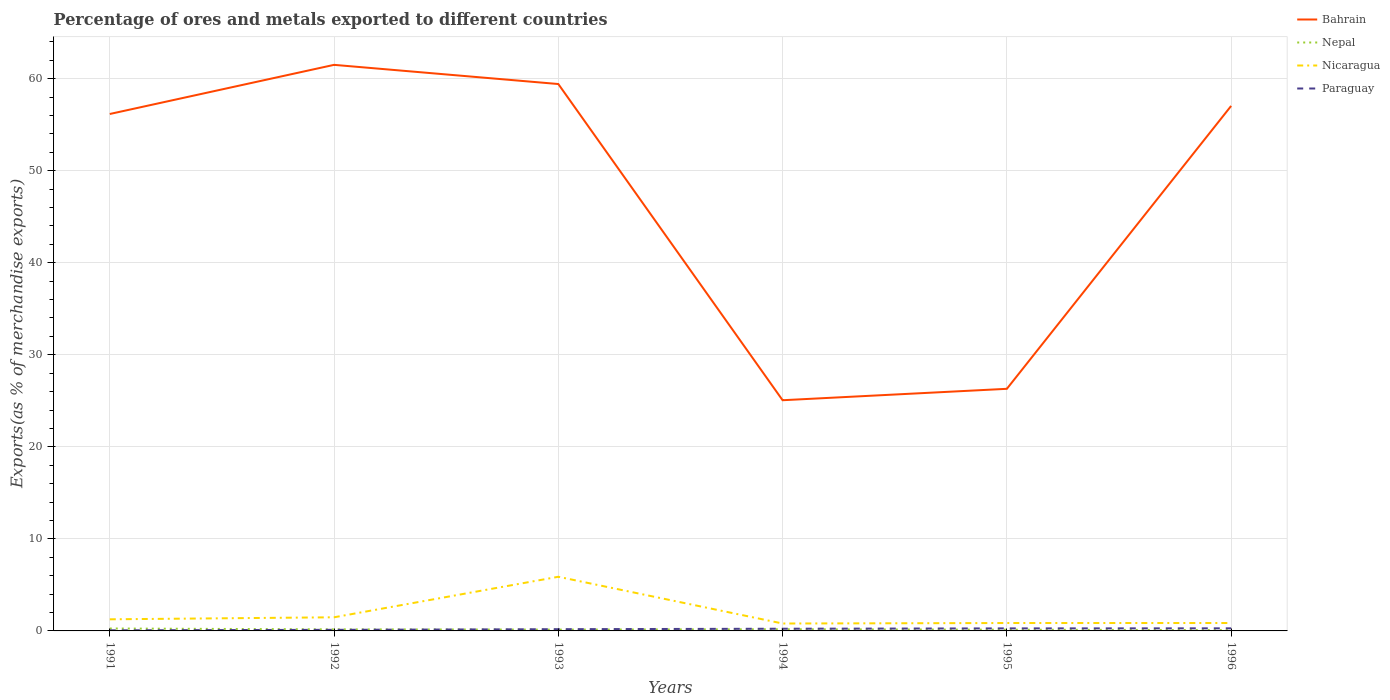How many different coloured lines are there?
Give a very brief answer. 4. Does the line corresponding to Bahrain intersect with the line corresponding to Paraguay?
Your response must be concise. No. Across all years, what is the maximum percentage of exports to different countries in Paraguay?
Provide a succinct answer. 0.06. In which year was the percentage of exports to different countries in Paraguay maximum?
Ensure brevity in your answer.  1991. What is the total percentage of exports to different countries in Nicaragua in the graph?
Ensure brevity in your answer.  5.03. What is the difference between the highest and the second highest percentage of exports to different countries in Bahrain?
Provide a short and direct response. 36.44. What is the difference between two consecutive major ticks on the Y-axis?
Provide a short and direct response. 10. Are the values on the major ticks of Y-axis written in scientific E-notation?
Your answer should be very brief. No. Does the graph contain any zero values?
Give a very brief answer. No. Does the graph contain grids?
Provide a succinct answer. Yes. How are the legend labels stacked?
Offer a very short reply. Vertical. What is the title of the graph?
Ensure brevity in your answer.  Percentage of ores and metals exported to different countries. Does "Small states" appear as one of the legend labels in the graph?
Ensure brevity in your answer.  No. What is the label or title of the Y-axis?
Give a very brief answer. Exports(as % of merchandise exports). What is the Exports(as % of merchandise exports) in Bahrain in 1991?
Offer a very short reply. 56.17. What is the Exports(as % of merchandise exports) in Nepal in 1991?
Keep it short and to the point. 0.26. What is the Exports(as % of merchandise exports) of Nicaragua in 1991?
Keep it short and to the point. 1.26. What is the Exports(as % of merchandise exports) in Paraguay in 1991?
Your answer should be very brief. 0.06. What is the Exports(as % of merchandise exports) in Bahrain in 1992?
Keep it short and to the point. 61.5. What is the Exports(as % of merchandise exports) of Nepal in 1992?
Your response must be concise. 0.17. What is the Exports(as % of merchandise exports) in Nicaragua in 1992?
Offer a very short reply. 1.48. What is the Exports(as % of merchandise exports) of Paraguay in 1992?
Make the answer very short. 0.12. What is the Exports(as % of merchandise exports) of Bahrain in 1993?
Ensure brevity in your answer.  59.42. What is the Exports(as % of merchandise exports) of Nepal in 1993?
Provide a succinct answer. 0.14. What is the Exports(as % of merchandise exports) in Nicaragua in 1993?
Provide a succinct answer. 5.88. What is the Exports(as % of merchandise exports) in Paraguay in 1993?
Give a very brief answer. 0.19. What is the Exports(as % of merchandise exports) of Bahrain in 1994?
Your answer should be very brief. 25.07. What is the Exports(as % of merchandise exports) in Nepal in 1994?
Your answer should be compact. 0.19. What is the Exports(as % of merchandise exports) of Nicaragua in 1994?
Offer a terse response. 0.81. What is the Exports(as % of merchandise exports) of Paraguay in 1994?
Your response must be concise. 0.24. What is the Exports(as % of merchandise exports) of Bahrain in 1995?
Your answer should be very brief. 26.31. What is the Exports(as % of merchandise exports) of Nepal in 1995?
Your answer should be very brief. 0.13. What is the Exports(as % of merchandise exports) in Nicaragua in 1995?
Your answer should be compact. 0.86. What is the Exports(as % of merchandise exports) of Paraguay in 1995?
Offer a very short reply. 0.27. What is the Exports(as % of merchandise exports) of Bahrain in 1996?
Offer a very short reply. 57.04. What is the Exports(as % of merchandise exports) of Nepal in 1996?
Offer a very short reply. 0.09. What is the Exports(as % of merchandise exports) of Nicaragua in 1996?
Make the answer very short. 0.86. What is the Exports(as % of merchandise exports) in Paraguay in 1996?
Ensure brevity in your answer.  0.28. Across all years, what is the maximum Exports(as % of merchandise exports) in Bahrain?
Provide a succinct answer. 61.5. Across all years, what is the maximum Exports(as % of merchandise exports) in Nepal?
Offer a terse response. 0.26. Across all years, what is the maximum Exports(as % of merchandise exports) of Nicaragua?
Your response must be concise. 5.88. Across all years, what is the maximum Exports(as % of merchandise exports) in Paraguay?
Give a very brief answer. 0.28. Across all years, what is the minimum Exports(as % of merchandise exports) of Bahrain?
Ensure brevity in your answer.  25.07. Across all years, what is the minimum Exports(as % of merchandise exports) in Nepal?
Offer a very short reply. 0.09. Across all years, what is the minimum Exports(as % of merchandise exports) of Nicaragua?
Your answer should be very brief. 0.81. Across all years, what is the minimum Exports(as % of merchandise exports) in Paraguay?
Keep it short and to the point. 0.06. What is the total Exports(as % of merchandise exports) of Bahrain in the graph?
Offer a terse response. 285.5. What is the total Exports(as % of merchandise exports) in Nepal in the graph?
Provide a short and direct response. 0.98. What is the total Exports(as % of merchandise exports) in Nicaragua in the graph?
Provide a succinct answer. 11.15. What is the total Exports(as % of merchandise exports) of Paraguay in the graph?
Ensure brevity in your answer.  1.17. What is the difference between the Exports(as % of merchandise exports) of Bahrain in 1991 and that in 1992?
Keep it short and to the point. -5.34. What is the difference between the Exports(as % of merchandise exports) in Nepal in 1991 and that in 1992?
Provide a short and direct response. 0.09. What is the difference between the Exports(as % of merchandise exports) in Nicaragua in 1991 and that in 1992?
Your answer should be compact. -0.22. What is the difference between the Exports(as % of merchandise exports) of Paraguay in 1991 and that in 1992?
Provide a short and direct response. -0.06. What is the difference between the Exports(as % of merchandise exports) in Bahrain in 1991 and that in 1993?
Offer a very short reply. -3.25. What is the difference between the Exports(as % of merchandise exports) in Nepal in 1991 and that in 1993?
Your response must be concise. 0.12. What is the difference between the Exports(as % of merchandise exports) of Nicaragua in 1991 and that in 1993?
Your answer should be compact. -4.62. What is the difference between the Exports(as % of merchandise exports) in Paraguay in 1991 and that in 1993?
Keep it short and to the point. -0.12. What is the difference between the Exports(as % of merchandise exports) of Bahrain in 1991 and that in 1994?
Offer a terse response. 31.1. What is the difference between the Exports(as % of merchandise exports) in Nepal in 1991 and that in 1994?
Provide a succinct answer. 0.08. What is the difference between the Exports(as % of merchandise exports) of Nicaragua in 1991 and that in 1994?
Provide a succinct answer. 0.46. What is the difference between the Exports(as % of merchandise exports) in Paraguay in 1991 and that in 1994?
Provide a succinct answer. -0.18. What is the difference between the Exports(as % of merchandise exports) in Bahrain in 1991 and that in 1995?
Make the answer very short. 29.86. What is the difference between the Exports(as % of merchandise exports) of Nepal in 1991 and that in 1995?
Offer a very short reply. 0.13. What is the difference between the Exports(as % of merchandise exports) of Nicaragua in 1991 and that in 1995?
Give a very brief answer. 0.4. What is the difference between the Exports(as % of merchandise exports) of Paraguay in 1991 and that in 1995?
Give a very brief answer. -0.21. What is the difference between the Exports(as % of merchandise exports) in Bahrain in 1991 and that in 1996?
Make the answer very short. -0.88. What is the difference between the Exports(as % of merchandise exports) in Nepal in 1991 and that in 1996?
Give a very brief answer. 0.17. What is the difference between the Exports(as % of merchandise exports) of Nicaragua in 1991 and that in 1996?
Keep it short and to the point. 0.4. What is the difference between the Exports(as % of merchandise exports) in Paraguay in 1991 and that in 1996?
Your answer should be very brief. -0.22. What is the difference between the Exports(as % of merchandise exports) in Bahrain in 1992 and that in 1993?
Ensure brevity in your answer.  2.08. What is the difference between the Exports(as % of merchandise exports) of Nepal in 1992 and that in 1993?
Your answer should be very brief. 0.03. What is the difference between the Exports(as % of merchandise exports) in Nicaragua in 1992 and that in 1993?
Make the answer very short. -4.4. What is the difference between the Exports(as % of merchandise exports) of Paraguay in 1992 and that in 1993?
Offer a terse response. -0.07. What is the difference between the Exports(as % of merchandise exports) in Bahrain in 1992 and that in 1994?
Offer a very short reply. 36.44. What is the difference between the Exports(as % of merchandise exports) of Nepal in 1992 and that in 1994?
Offer a terse response. -0.02. What is the difference between the Exports(as % of merchandise exports) in Nicaragua in 1992 and that in 1994?
Offer a very short reply. 0.68. What is the difference between the Exports(as % of merchandise exports) of Paraguay in 1992 and that in 1994?
Provide a succinct answer. -0.12. What is the difference between the Exports(as % of merchandise exports) in Bahrain in 1992 and that in 1995?
Your answer should be very brief. 35.2. What is the difference between the Exports(as % of merchandise exports) of Nepal in 1992 and that in 1995?
Provide a short and direct response. 0.04. What is the difference between the Exports(as % of merchandise exports) of Nicaragua in 1992 and that in 1995?
Make the answer very short. 0.62. What is the difference between the Exports(as % of merchandise exports) of Paraguay in 1992 and that in 1995?
Provide a short and direct response. -0.16. What is the difference between the Exports(as % of merchandise exports) of Bahrain in 1992 and that in 1996?
Provide a short and direct response. 4.46. What is the difference between the Exports(as % of merchandise exports) of Nepal in 1992 and that in 1996?
Your answer should be very brief. 0.08. What is the difference between the Exports(as % of merchandise exports) in Nicaragua in 1992 and that in 1996?
Provide a succinct answer. 0.62. What is the difference between the Exports(as % of merchandise exports) in Paraguay in 1992 and that in 1996?
Make the answer very short. -0.16. What is the difference between the Exports(as % of merchandise exports) of Bahrain in 1993 and that in 1994?
Ensure brevity in your answer.  34.35. What is the difference between the Exports(as % of merchandise exports) of Nepal in 1993 and that in 1994?
Ensure brevity in your answer.  -0.04. What is the difference between the Exports(as % of merchandise exports) in Nicaragua in 1993 and that in 1994?
Your answer should be very brief. 5.08. What is the difference between the Exports(as % of merchandise exports) of Paraguay in 1993 and that in 1994?
Offer a terse response. -0.05. What is the difference between the Exports(as % of merchandise exports) of Bahrain in 1993 and that in 1995?
Your answer should be very brief. 33.11. What is the difference between the Exports(as % of merchandise exports) in Nepal in 1993 and that in 1995?
Your answer should be very brief. 0.01. What is the difference between the Exports(as % of merchandise exports) of Nicaragua in 1993 and that in 1995?
Your answer should be compact. 5.03. What is the difference between the Exports(as % of merchandise exports) of Paraguay in 1993 and that in 1995?
Offer a terse response. -0.09. What is the difference between the Exports(as % of merchandise exports) in Bahrain in 1993 and that in 1996?
Your response must be concise. 2.38. What is the difference between the Exports(as % of merchandise exports) in Nepal in 1993 and that in 1996?
Provide a succinct answer. 0.05. What is the difference between the Exports(as % of merchandise exports) of Nicaragua in 1993 and that in 1996?
Make the answer very short. 5.02. What is the difference between the Exports(as % of merchandise exports) in Paraguay in 1993 and that in 1996?
Your answer should be very brief. -0.09. What is the difference between the Exports(as % of merchandise exports) in Bahrain in 1994 and that in 1995?
Offer a very short reply. -1.24. What is the difference between the Exports(as % of merchandise exports) of Nepal in 1994 and that in 1995?
Ensure brevity in your answer.  0.05. What is the difference between the Exports(as % of merchandise exports) in Nicaragua in 1994 and that in 1995?
Offer a terse response. -0.05. What is the difference between the Exports(as % of merchandise exports) in Paraguay in 1994 and that in 1995?
Make the answer very short. -0.04. What is the difference between the Exports(as % of merchandise exports) of Bahrain in 1994 and that in 1996?
Your answer should be very brief. -31.98. What is the difference between the Exports(as % of merchandise exports) in Nepal in 1994 and that in 1996?
Give a very brief answer. 0.1. What is the difference between the Exports(as % of merchandise exports) in Nicaragua in 1994 and that in 1996?
Your answer should be very brief. -0.05. What is the difference between the Exports(as % of merchandise exports) in Paraguay in 1994 and that in 1996?
Keep it short and to the point. -0.04. What is the difference between the Exports(as % of merchandise exports) of Bahrain in 1995 and that in 1996?
Your response must be concise. -30.74. What is the difference between the Exports(as % of merchandise exports) of Nepal in 1995 and that in 1996?
Your answer should be compact. 0.05. What is the difference between the Exports(as % of merchandise exports) in Nicaragua in 1995 and that in 1996?
Offer a very short reply. -0. What is the difference between the Exports(as % of merchandise exports) in Paraguay in 1995 and that in 1996?
Your response must be concise. -0.01. What is the difference between the Exports(as % of merchandise exports) of Bahrain in 1991 and the Exports(as % of merchandise exports) of Nepal in 1992?
Offer a terse response. 56. What is the difference between the Exports(as % of merchandise exports) in Bahrain in 1991 and the Exports(as % of merchandise exports) in Nicaragua in 1992?
Your answer should be very brief. 54.68. What is the difference between the Exports(as % of merchandise exports) in Bahrain in 1991 and the Exports(as % of merchandise exports) in Paraguay in 1992?
Give a very brief answer. 56.05. What is the difference between the Exports(as % of merchandise exports) in Nepal in 1991 and the Exports(as % of merchandise exports) in Nicaragua in 1992?
Provide a succinct answer. -1.22. What is the difference between the Exports(as % of merchandise exports) in Nepal in 1991 and the Exports(as % of merchandise exports) in Paraguay in 1992?
Ensure brevity in your answer.  0.14. What is the difference between the Exports(as % of merchandise exports) in Nicaragua in 1991 and the Exports(as % of merchandise exports) in Paraguay in 1992?
Offer a terse response. 1.14. What is the difference between the Exports(as % of merchandise exports) of Bahrain in 1991 and the Exports(as % of merchandise exports) of Nepal in 1993?
Offer a very short reply. 56.02. What is the difference between the Exports(as % of merchandise exports) in Bahrain in 1991 and the Exports(as % of merchandise exports) in Nicaragua in 1993?
Give a very brief answer. 50.28. What is the difference between the Exports(as % of merchandise exports) of Bahrain in 1991 and the Exports(as % of merchandise exports) of Paraguay in 1993?
Your response must be concise. 55.98. What is the difference between the Exports(as % of merchandise exports) in Nepal in 1991 and the Exports(as % of merchandise exports) in Nicaragua in 1993?
Make the answer very short. -5.62. What is the difference between the Exports(as % of merchandise exports) of Nepal in 1991 and the Exports(as % of merchandise exports) of Paraguay in 1993?
Your response must be concise. 0.07. What is the difference between the Exports(as % of merchandise exports) of Nicaragua in 1991 and the Exports(as % of merchandise exports) of Paraguay in 1993?
Give a very brief answer. 1.07. What is the difference between the Exports(as % of merchandise exports) of Bahrain in 1991 and the Exports(as % of merchandise exports) of Nepal in 1994?
Your response must be concise. 55.98. What is the difference between the Exports(as % of merchandise exports) of Bahrain in 1991 and the Exports(as % of merchandise exports) of Nicaragua in 1994?
Make the answer very short. 55.36. What is the difference between the Exports(as % of merchandise exports) in Bahrain in 1991 and the Exports(as % of merchandise exports) in Paraguay in 1994?
Keep it short and to the point. 55.93. What is the difference between the Exports(as % of merchandise exports) of Nepal in 1991 and the Exports(as % of merchandise exports) of Nicaragua in 1994?
Provide a succinct answer. -0.54. What is the difference between the Exports(as % of merchandise exports) of Nepal in 1991 and the Exports(as % of merchandise exports) of Paraguay in 1994?
Offer a very short reply. 0.02. What is the difference between the Exports(as % of merchandise exports) in Nicaragua in 1991 and the Exports(as % of merchandise exports) in Paraguay in 1994?
Offer a terse response. 1.02. What is the difference between the Exports(as % of merchandise exports) in Bahrain in 1991 and the Exports(as % of merchandise exports) in Nepal in 1995?
Ensure brevity in your answer.  56.03. What is the difference between the Exports(as % of merchandise exports) in Bahrain in 1991 and the Exports(as % of merchandise exports) in Nicaragua in 1995?
Offer a very short reply. 55.31. What is the difference between the Exports(as % of merchandise exports) of Bahrain in 1991 and the Exports(as % of merchandise exports) of Paraguay in 1995?
Your answer should be very brief. 55.89. What is the difference between the Exports(as % of merchandise exports) of Nepal in 1991 and the Exports(as % of merchandise exports) of Nicaragua in 1995?
Your answer should be compact. -0.6. What is the difference between the Exports(as % of merchandise exports) in Nepal in 1991 and the Exports(as % of merchandise exports) in Paraguay in 1995?
Your response must be concise. -0.01. What is the difference between the Exports(as % of merchandise exports) in Nicaragua in 1991 and the Exports(as % of merchandise exports) in Paraguay in 1995?
Ensure brevity in your answer.  0.99. What is the difference between the Exports(as % of merchandise exports) of Bahrain in 1991 and the Exports(as % of merchandise exports) of Nepal in 1996?
Your answer should be very brief. 56.08. What is the difference between the Exports(as % of merchandise exports) of Bahrain in 1991 and the Exports(as % of merchandise exports) of Nicaragua in 1996?
Keep it short and to the point. 55.31. What is the difference between the Exports(as % of merchandise exports) in Bahrain in 1991 and the Exports(as % of merchandise exports) in Paraguay in 1996?
Give a very brief answer. 55.88. What is the difference between the Exports(as % of merchandise exports) in Nepal in 1991 and the Exports(as % of merchandise exports) in Nicaragua in 1996?
Your answer should be very brief. -0.6. What is the difference between the Exports(as % of merchandise exports) in Nepal in 1991 and the Exports(as % of merchandise exports) in Paraguay in 1996?
Provide a short and direct response. -0.02. What is the difference between the Exports(as % of merchandise exports) of Nicaragua in 1991 and the Exports(as % of merchandise exports) of Paraguay in 1996?
Ensure brevity in your answer.  0.98. What is the difference between the Exports(as % of merchandise exports) in Bahrain in 1992 and the Exports(as % of merchandise exports) in Nepal in 1993?
Keep it short and to the point. 61.36. What is the difference between the Exports(as % of merchandise exports) of Bahrain in 1992 and the Exports(as % of merchandise exports) of Nicaragua in 1993?
Provide a short and direct response. 55.62. What is the difference between the Exports(as % of merchandise exports) of Bahrain in 1992 and the Exports(as % of merchandise exports) of Paraguay in 1993?
Your answer should be very brief. 61.32. What is the difference between the Exports(as % of merchandise exports) of Nepal in 1992 and the Exports(as % of merchandise exports) of Nicaragua in 1993?
Your answer should be very brief. -5.71. What is the difference between the Exports(as % of merchandise exports) in Nepal in 1992 and the Exports(as % of merchandise exports) in Paraguay in 1993?
Provide a short and direct response. -0.02. What is the difference between the Exports(as % of merchandise exports) in Nicaragua in 1992 and the Exports(as % of merchandise exports) in Paraguay in 1993?
Offer a terse response. 1.29. What is the difference between the Exports(as % of merchandise exports) in Bahrain in 1992 and the Exports(as % of merchandise exports) in Nepal in 1994?
Provide a succinct answer. 61.32. What is the difference between the Exports(as % of merchandise exports) in Bahrain in 1992 and the Exports(as % of merchandise exports) in Nicaragua in 1994?
Your response must be concise. 60.7. What is the difference between the Exports(as % of merchandise exports) of Bahrain in 1992 and the Exports(as % of merchandise exports) of Paraguay in 1994?
Ensure brevity in your answer.  61.27. What is the difference between the Exports(as % of merchandise exports) in Nepal in 1992 and the Exports(as % of merchandise exports) in Nicaragua in 1994?
Your answer should be compact. -0.64. What is the difference between the Exports(as % of merchandise exports) in Nepal in 1992 and the Exports(as % of merchandise exports) in Paraguay in 1994?
Your answer should be compact. -0.07. What is the difference between the Exports(as % of merchandise exports) of Nicaragua in 1992 and the Exports(as % of merchandise exports) of Paraguay in 1994?
Provide a succinct answer. 1.24. What is the difference between the Exports(as % of merchandise exports) in Bahrain in 1992 and the Exports(as % of merchandise exports) in Nepal in 1995?
Offer a very short reply. 61.37. What is the difference between the Exports(as % of merchandise exports) in Bahrain in 1992 and the Exports(as % of merchandise exports) in Nicaragua in 1995?
Your response must be concise. 60.65. What is the difference between the Exports(as % of merchandise exports) in Bahrain in 1992 and the Exports(as % of merchandise exports) in Paraguay in 1995?
Your response must be concise. 61.23. What is the difference between the Exports(as % of merchandise exports) in Nepal in 1992 and the Exports(as % of merchandise exports) in Nicaragua in 1995?
Your answer should be very brief. -0.69. What is the difference between the Exports(as % of merchandise exports) of Nepal in 1992 and the Exports(as % of merchandise exports) of Paraguay in 1995?
Keep it short and to the point. -0.1. What is the difference between the Exports(as % of merchandise exports) in Nicaragua in 1992 and the Exports(as % of merchandise exports) in Paraguay in 1995?
Offer a very short reply. 1.21. What is the difference between the Exports(as % of merchandise exports) of Bahrain in 1992 and the Exports(as % of merchandise exports) of Nepal in 1996?
Your answer should be very brief. 61.42. What is the difference between the Exports(as % of merchandise exports) in Bahrain in 1992 and the Exports(as % of merchandise exports) in Nicaragua in 1996?
Your response must be concise. 60.64. What is the difference between the Exports(as % of merchandise exports) of Bahrain in 1992 and the Exports(as % of merchandise exports) of Paraguay in 1996?
Offer a terse response. 61.22. What is the difference between the Exports(as % of merchandise exports) of Nepal in 1992 and the Exports(as % of merchandise exports) of Nicaragua in 1996?
Give a very brief answer. -0.69. What is the difference between the Exports(as % of merchandise exports) in Nepal in 1992 and the Exports(as % of merchandise exports) in Paraguay in 1996?
Make the answer very short. -0.11. What is the difference between the Exports(as % of merchandise exports) in Nicaragua in 1992 and the Exports(as % of merchandise exports) in Paraguay in 1996?
Your answer should be very brief. 1.2. What is the difference between the Exports(as % of merchandise exports) of Bahrain in 1993 and the Exports(as % of merchandise exports) of Nepal in 1994?
Provide a short and direct response. 59.23. What is the difference between the Exports(as % of merchandise exports) in Bahrain in 1993 and the Exports(as % of merchandise exports) in Nicaragua in 1994?
Provide a short and direct response. 58.61. What is the difference between the Exports(as % of merchandise exports) in Bahrain in 1993 and the Exports(as % of merchandise exports) in Paraguay in 1994?
Make the answer very short. 59.18. What is the difference between the Exports(as % of merchandise exports) in Nepal in 1993 and the Exports(as % of merchandise exports) in Nicaragua in 1994?
Keep it short and to the point. -0.66. What is the difference between the Exports(as % of merchandise exports) of Nepal in 1993 and the Exports(as % of merchandise exports) of Paraguay in 1994?
Your response must be concise. -0.1. What is the difference between the Exports(as % of merchandise exports) of Nicaragua in 1993 and the Exports(as % of merchandise exports) of Paraguay in 1994?
Your response must be concise. 5.64. What is the difference between the Exports(as % of merchandise exports) in Bahrain in 1993 and the Exports(as % of merchandise exports) in Nepal in 1995?
Provide a short and direct response. 59.28. What is the difference between the Exports(as % of merchandise exports) of Bahrain in 1993 and the Exports(as % of merchandise exports) of Nicaragua in 1995?
Offer a very short reply. 58.56. What is the difference between the Exports(as % of merchandise exports) of Bahrain in 1993 and the Exports(as % of merchandise exports) of Paraguay in 1995?
Your response must be concise. 59.15. What is the difference between the Exports(as % of merchandise exports) of Nepal in 1993 and the Exports(as % of merchandise exports) of Nicaragua in 1995?
Provide a short and direct response. -0.72. What is the difference between the Exports(as % of merchandise exports) in Nepal in 1993 and the Exports(as % of merchandise exports) in Paraguay in 1995?
Provide a succinct answer. -0.13. What is the difference between the Exports(as % of merchandise exports) in Nicaragua in 1993 and the Exports(as % of merchandise exports) in Paraguay in 1995?
Provide a short and direct response. 5.61. What is the difference between the Exports(as % of merchandise exports) in Bahrain in 1993 and the Exports(as % of merchandise exports) in Nepal in 1996?
Your answer should be very brief. 59.33. What is the difference between the Exports(as % of merchandise exports) in Bahrain in 1993 and the Exports(as % of merchandise exports) in Nicaragua in 1996?
Your response must be concise. 58.56. What is the difference between the Exports(as % of merchandise exports) in Bahrain in 1993 and the Exports(as % of merchandise exports) in Paraguay in 1996?
Make the answer very short. 59.14. What is the difference between the Exports(as % of merchandise exports) in Nepal in 1993 and the Exports(as % of merchandise exports) in Nicaragua in 1996?
Your answer should be compact. -0.72. What is the difference between the Exports(as % of merchandise exports) of Nepal in 1993 and the Exports(as % of merchandise exports) of Paraguay in 1996?
Offer a very short reply. -0.14. What is the difference between the Exports(as % of merchandise exports) in Nicaragua in 1993 and the Exports(as % of merchandise exports) in Paraguay in 1996?
Your answer should be very brief. 5.6. What is the difference between the Exports(as % of merchandise exports) in Bahrain in 1994 and the Exports(as % of merchandise exports) in Nepal in 1995?
Provide a short and direct response. 24.93. What is the difference between the Exports(as % of merchandise exports) of Bahrain in 1994 and the Exports(as % of merchandise exports) of Nicaragua in 1995?
Your answer should be compact. 24.21. What is the difference between the Exports(as % of merchandise exports) in Bahrain in 1994 and the Exports(as % of merchandise exports) in Paraguay in 1995?
Give a very brief answer. 24.79. What is the difference between the Exports(as % of merchandise exports) of Nepal in 1994 and the Exports(as % of merchandise exports) of Nicaragua in 1995?
Keep it short and to the point. -0.67. What is the difference between the Exports(as % of merchandise exports) of Nepal in 1994 and the Exports(as % of merchandise exports) of Paraguay in 1995?
Your answer should be very brief. -0.09. What is the difference between the Exports(as % of merchandise exports) in Nicaragua in 1994 and the Exports(as % of merchandise exports) in Paraguay in 1995?
Offer a very short reply. 0.53. What is the difference between the Exports(as % of merchandise exports) in Bahrain in 1994 and the Exports(as % of merchandise exports) in Nepal in 1996?
Your answer should be very brief. 24.98. What is the difference between the Exports(as % of merchandise exports) in Bahrain in 1994 and the Exports(as % of merchandise exports) in Nicaragua in 1996?
Give a very brief answer. 24.21. What is the difference between the Exports(as % of merchandise exports) in Bahrain in 1994 and the Exports(as % of merchandise exports) in Paraguay in 1996?
Make the answer very short. 24.78. What is the difference between the Exports(as % of merchandise exports) of Nepal in 1994 and the Exports(as % of merchandise exports) of Nicaragua in 1996?
Offer a very short reply. -0.67. What is the difference between the Exports(as % of merchandise exports) in Nepal in 1994 and the Exports(as % of merchandise exports) in Paraguay in 1996?
Your response must be concise. -0.1. What is the difference between the Exports(as % of merchandise exports) in Nicaragua in 1994 and the Exports(as % of merchandise exports) in Paraguay in 1996?
Your answer should be very brief. 0.52. What is the difference between the Exports(as % of merchandise exports) in Bahrain in 1995 and the Exports(as % of merchandise exports) in Nepal in 1996?
Your answer should be compact. 26.22. What is the difference between the Exports(as % of merchandise exports) of Bahrain in 1995 and the Exports(as % of merchandise exports) of Nicaragua in 1996?
Offer a terse response. 25.45. What is the difference between the Exports(as % of merchandise exports) in Bahrain in 1995 and the Exports(as % of merchandise exports) in Paraguay in 1996?
Offer a terse response. 26.02. What is the difference between the Exports(as % of merchandise exports) of Nepal in 1995 and the Exports(as % of merchandise exports) of Nicaragua in 1996?
Keep it short and to the point. -0.72. What is the difference between the Exports(as % of merchandise exports) in Nepal in 1995 and the Exports(as % of merchandise exports) in Paraguay in 1996?
Your answer should be compact. -0.15. What is the difference between the Exports(as % of merchandise exports) in Nicaragua in 1995 and the Exports(as % of merchandise exports) in Paraguay in 1996?
Provide a succinct answer. 0.58. What is the average Exports(as % of merchandise exports) of Bahrain per year?
Provide a short and direct response. 47.58. What is the average Exports(as % of merchandise exports) in Nepal per year?
Offer a terse response. 0.16. What is the average Exports(as % of merchandise exports) of Nicaragua per year?
Provide a succinct answer. 1.86. What is the average Exports(as % of merchandise exports) of Paraguay per year?
Offer a very short reply. 0.19. In the year 1991, what is the difference between the Exports(as % of merchandise exports) of Bahrain and Exports(as % of merchandise exports) of Nepal?
Your response must be concise. 55.9. In the year 1991, what is the difference between the Exports(as % of merchandise exports) of Bahrain and Exports(as % of merchandise exports) of Nicaragua?
Give a very brief answer. 54.9. In the year 1991, what is the difference between the Exports(as % of merchandise exports) of Bahrain and Exports(as % of merchandise exports) of Paraguay?
Your answer should be compact. 56.1. In the year 1991, what is the difference between the Exports(as % of merchandise exports) of Nepal and Exports(as % of merchandise exports) of Nicaragua?
Give a very brief answer. -1. In the year 1991, what is the difference between the Exports(as % of merchandise exports) in Nepal and Exports(as % of merchandise exports) in Paraguay?
Offer a very short reply. 0.2. In the year 1991, what is the difference between the Exports(as % of merchandise exports) of Nicaragua and Exports(as % of merchandise exports) of Paraguay?
Offer a terse response. 1.2. In the year 1992, what is the difference between the Exports(as % of merchandise exports) in Bahrain and Exports(as % of merchandise exports) in Nepal?
Offer a very short reply. 61.33. In the year 1992, what is the difference between the Exports(as % of merchandise exports) in Bahrain and Exports(as % of merchandise exports) in Nicaragua?
Your answer should be very brief. 60.02. In the year 1992, what is the difference between the Exports(as % of merchandise exports) in Bahrain and Exports(as % of merchandise exports) in Paraguay?
Your answer should be very brief. 61.38. In the year 1992, what is the difference between the Exports(as % of merchandise exports) of Nepal and Exports(as % of merchandise exports) of Nicaragua?
Provide a succinct answer. -1.31. In the year 1992, what is the difference between the Exports(as % of merchandise exports) of Nepal and Exports(as % of merchandise exports) of Paraguay?
Make the answer very short. 0.05. In the year 1992, what is the difference between the Exports(as % of merchandise exports) in Nicaragua and Exports(as % of merchandise exports) in Paraguay?
Provide a short and direct response. 1.36. In the year 1993, what is the difference between the Exports(as % of merchandise exports) in Bahrain and Exports(as % of merchandise exports) in Nepal?
Your answer should be very brief. 59.28. In the year 1993, what is the difference between the Exports(as % of merchandise exports) of Bahrain and Exports(as % of merchandise exports) of Nicaragua?
Keep it short and to the point. 53.54. In the year 1993, what is the difference between the Exports(as % of merchandise exports) in Bahrain and Exports(as % of merchandise exports) in Paraguay?
Provide a succinct answer. 59.23. In the year 1993, what is the difference between the Exports(as % of merchandise exports) in Nepal and Exports(as % of merchandise exports) in Nicaragua?
Your answer should be very brief. -5.74. In the year 1993, what is the difference between the Exports(as % of merchandise exports) in Nepal and Exports(as % of merchandise exports) in Paraguay?
Offer a terse response. -0.05. In the year 1993, what is the difference between the Exports(as % of merchandise exports) of Nicaragua and Exports(as % of merchandise exports) of Paraguay?
Make the answer very short. 5.7. In the year 1994, what is the difference between the Exports(as % of merchandise exports) in Bahrain and Exports(as % of merchandise exports) in Nepal?
Ensure brevity in your answer.  24.88. In the year 1994, what is the difference between the Exports(as % of merchandise exports) in Bahrain and Exports(as % of merchandise exports) in Nicaragua?
Your answer should be compact. 24.26. In the year 1994, what is the difference between the Exports(as % of merchandise exports) of Bahrain and Exports(as % of merchandise exports) of Paraguay?
Give a very brief answer. 24.83. In the year 1994, what is the difference between the Exports(as % of merchandise exports) of Nepal and Exports(as % of merchandise exports) of Nicaragua?
Keep it short and to the point. -0.62. In the year 1994, what is the difference between the Exports(as % of merchandise exports) of Nepal and Exports(as % of merchandise exports) of Paraguay?
Provide a short and direct response. -0.05. In the year 1994, what is the difference between the Exports(as % of merchandise exports) of Nicaragua and Exports(as % of merchandise exports) of Paraguay?
Provide a short and direct response. 0.57. In the year 1995, what is the difference between the Exports(as % of merchandise exports) of Bahrain and Exports(as % of merchandise exports) of Nepal?
Provide a succinct answer. 26.17. In the year 1995, what is the difference between the Exports(as % of merchandise exports) in Bahrain and Exports(as % of merchandise exports) in Nicaragua?
Ensure brevity in your answer.  25.45. In the year 1995, what is the difference between the Exports(as % of merchandise exports) of Bahrain and Exports(as % of merchandise exports) of Paraguay?
Keep it short and to the point. 26.03. In the year 1995, what is the difference between the Exports(as % of merchandise exports) in Nepal and Exports(as % of merchandise exports) in Nicaragua?
Your response must be concise. -0.72. In the year 1995, what is the difference between the Exports(as % of merchandise exports) of Nepal and Exports(as % of merchandise exports) of Paraguay?
Your answer should be very brief. -0.14. In the year 1995, what is the difference between the Exports(as % of merchandise exports) in Nicaragua and Exports(as % of merchandise exports) in Paraguay?
Make the answer very short. 0.58. In the year 1996, what is the difference between the Exports(as % of merchandise exports) of Bahrain and Exports(as % of merchandise exports) of Nepal?
Your answer should be very brief. 56.95. In the year 1996, what is the difference between the Exports(as % of merchandise exports) in Bahrain and Exports(as % of merchandise exports) in Nicaragua?
Make the answer very short. 56.18. In the year 1996, what is the difference between the Exports(as % of merchandise exports) of Bahrain and Exports(as % of merchandise exports) of Paraguay?
Give a very brief answer. 56.76. In the year 1996, what is the difference between the Exports(as % of merchandise exports) of Nepal and Exports(as % of merchandise exports) of Nicaragua?
Your answer should be compact. -0.77. In the year 1996, what is the difference between the Exports(as % of merchandise exports) in Nepal and Exports(as % of merchandise exports) in Paraguay?
Make the answer very short. -0.19. In the year 1996, what is the difference between the Exports(as % of merchandise exports) of Nicaragua and Exports(as % of merchandise exports) of Paraguay?
Make the answer very short. 0.58. What is the ratio of the Exports(as % of merchandise exports) of Bahrain in 1991 to that in 1992?
Ensure brevity in your answer.  0.91. What is the ratio of the Exports(as % of merchandise exports) of Nepal in 1991 to that in 1992?
Ensure brevity in your answer.  1.54. What is the ratio of the Exports(as % of merchandise exports) of Nicaragua in 1991 to that in 1992?
Your answer should be very brief. 0.85. What is the ratio of the Exports(as % of merchandise exports) of Paraguay in 1991 to that in 1992?
Offer a terse response. 0.53. What is the ratio of the Exports(as % of merchandise exports) of Bahrain in 1991 to that in 1993?
Provide a succinct answer. 0.95. What is the ratio of the Exports(as % of merchandise exports) of Nepal in 1991 to that in 1993?
Offer a very short reply. 1.85. What is the ratio of the Exports(as % of merchandise exports) of Nicaragua in 1991 to that in 1993?
Your answer should be very brief. 0.21. What is the ratio of the Exports(as % of merchandise exports) of Paraguay in 1991 to that in 1993?
Provide a short and direct response. 0.34. What is the ratio of the Exports(as % of merchandise exports) in Bahrain in 1991 to that in 1994?
Your response must be concise. 2.24. What is the ratio of the Exports(as % of merchandise exports) of Nepal in 1991 to that in 1994?
Offer a very short reply. 1.42. What is the ratio of the Exports(as % of merchandise exports) of Nicaragua in 1991 to that in 1994?
Give a very brief answer. 1.57. What is the ratio of the Exports(as % of merchandise exports) in Paraguay in 1991 to that in 1994?
Your answer should be compact. 0.27. What is the ratio of the Exports(as % of merchandise exports) in Bahrain in 1991 to that in 1995?
Provide a succinct answer. 2.14. What is the ratio of the Exports(as % of merchandise exports) in Nepal in 1991 to that in 1995?
Ensure brevity in your answer.  1.95. What is the ratio of the Exports(as % of merchandise exports) in Nicaragua in 1991 to that in 1995?
Your answer should be very brief. 1.47. What is the ratio of the Exports(as % of merchandise exports) of Paraguay in 1991 to that in 1995?
Offer a very short reply. 0.23. What is the ratio of the Exports(as % of merchandise exports) in Bahrain in 1991 to that in 1996?
Offer a very short reply. 0.98. What is the ratio of the Exports(as % of merchandise exports) of Nepal in 1991 to that in 1996?
Provide a short and direct response. 2.99. What is the ratio of the Exports(as % of merchandise exports) of Nicaragua in 1991 to that in 1996?
Your answer should be compact. 1.47. What is the ratio of the Exports(as % of merchandise exports) in Paraguay in 1991 to that in 1996?
Ensure brevity in your answer.  0.23. What is the ratio of the Exports(as % of merchandise exports) of Bahrain in 1992 to that in 1993?
Your answer should be very brief. 1.04. What is the ratio of the Exports(as % of merchandise exports) in Nepal in 1992 to that in 1993?
Give a very brief answer. 1.2. What is the ratio of the Exports(as % of merchandise exports) of Nicaragua in 1992 to that in 1993?
Ensure brevity in your answer.  0.25. What is the ratio of the Exports(as % of merchandise exports) in Paraguay in 1992 to that in 1993?
Offer a terse response. 0.64. What is the ratio of the Exports(as % of merchandise exports) of Bahrain in 1992 to that in 1994?
Your answer should be compact. 2.45. What is the ratio of the Exports(as % of merchandise exports) of Nepal in 1992 to that in 1994?
Offer a terse response. 0.92. What is the ratio of the Exports(as % of merchandise exports) in Nicaragua in 1992 to that in 1994?
Your answer should be very brief. 1.84. What is the ratio of the Exports(as % of merchandise exports) of Paraguay in 1992 to that in 1994?
Give a very brief answer. 0.5. What is the ratio of the Exports(as % of merchandise exports) of Bahrain in 1992 to that in 1995?
Your answer should be very brief. 2.34. What is the ratio of the Exports(as % of merchandise exports) in Nepal in 1992 to that in 1995?
Provide a short and direct response. 1.26. What is the ratio of the Exports(as % of merchandise exports) of Nicaragua in 1992 to that in 1995?
Provide a succinct answer. 1.73. What is the ratio of the Exports(as % of merchandise exports) in Paraguay in 1992 to that in 1995?
Offer a terse response. 0.44. What is the ratio of the Exports(as % of merchandise exports) in Bahrain in 1992 to that in 1996?
Provide a succinct answer. 1.08. What is the ratio of the Exports(as % of merchandise exports) in Nepal in 1992 to that in 1996?
Provide a succinct answer. 1.93. What is the ratio of the Exports(as % of merchandise exports) in Nicaragua in 1992 to that in 1996?
Give a very brief answer. 1.72. What is the ratio of the Exports(as % of merchandise exports) in Paraguay in 1992 to that in 1996?
Give a very brief answer. 0.43. What is the ratio of the Exports(as % of merchandise exports) of Bahrain in 1993 to that in 1994?
Your answer should be compact. 2.37. What is the ratio of the Exports(as % of merchandise exports) in Nepal in 1993 to that in 1994?
Keep it short and to the point. 0.77. What is the ratio of the Exports(as % of merchandise exports) in Nicaragua in 1993 to that in 1994?
Ensure brevity in your answer.  7.31. What is the ratio of the Exports(as % of merchandise exports) of Paraguay in 1993 to that in 1994?
Provide a short and direct response. 0.79. What is the ratio of the Exports(as % of merchandise exports) of Bahrain in 1993 to that in 1995?
Your answer should be very brief. 2.26. What is the ratio of the Exports(as % of merchandise exports) in Nepal in 1993 to that in 1995?
Your answer should be very brief. 1.05. What is the ratio of the Exports(as % of merchandise exports) of Nicaragua in 1993 to that in 1995?
Provide a succinct answer. 6.86. What is the ratio of the Exports(as % of merchandise exports) in Paraguay in 1993 to that in 1995?
Your response must be concise. 0.68. What is the ratio of the Exports(as % of merchandise exports) of Bahrain in 1993 to that in 1996?
Your answer should be compact. 1.04. What is the ratio of the Exports(as % of merchandise exports) of Nepal in 1993 to that in 1996?
Your response must be concise. 1.61. What is the ratio of the Exports(as % of merchandise exports) in Nicaragua in 1993 to that in 1996?
Make the answer very short. 6.85. What is the ratio of the Exports(as % of merchandise exports) in Paraguay in 1993 to that in 1996?
Make the answer very short. 0.67. What is the ratio of the Exports(as % of merchandise exports) of Bahrain in 1994 to that in 1995?
Provide a short and direct response. 0.95. What is the ratio of the Exports(as % of merchandise exports) of Nepal in 1994 to that in 1995?
Your answer should be compact. 1.37. What is the ratio of the Exports(as % of merchandise exports) in Nicaragua in 1994 to that in 1995?
Provide a short and direct response. 0.94. What is the ratio of the Exports(as % of merchandise exports) in Paraguay in 1994 to that in 1995?
Your answer should be very brief. 0.87. What is the ratio of the Exports(as % of merchandise exports) in Bahrain in 1994 to that in 1996?
Your answer should be very brief. 0.44. What is the ratio of the Exports(as % of merchandise exports) in Nepal in 1994 to that in 1996?
Your answer should be compact. 2.11. What is the ratio of the Exports(as % of merchandise exports) of Nicaragua in 1994 to that in 1996?
Your response must be concise. 0.94. What is the ratio of the Exports(as % of merchandise exports) in Paraguay in 1994 to that in 1996?
Your answer should be very brief. 0.85. What is the ratio of the Exports(as % of merchandise exports) in Bahrain in 1995 to that in 1996?
Your response must be concise. 0.46. What is the ratio of the Exports(as % of merchandise exports) in Nepal in 1995 to that in 1996?
Your answer should be very brief. 1.53. What is the ratio of the Exports(as % of merchandise exports) in Nicaragua in 1995 to that in 1996?
Ensure brevity in your answer.  1. What is the ratio of the Exports(as % of merchandise exports) in Paraguay in 1995 to that in 1996?
Ensure brevity in your answer.  0.98. What is the difference between the highest and the second highest Exports(as % of merchandise exports) of Bahrain?
Your answer should be very brief. 2.08. What is the difference between the highest and the second highest Exports(as % of merchandise exports) in Nepal?
Your answer should be very brief. 0.08. What is the difference between the highest and the second highest Exports(as % of merchandise exports) of Nicaragua?
Give a very brief answer. 4.4. What is the difference between the highest and the second highest Exports(as % of merchandise exports) of Paraguay?
Provide a succinct answer. 0.01. What is the difference between the highest and the lowest Exports(as % of merchandise exports) of Bahrain?
Keep it short and to the point. 36.44. What is the difference between the highest and the lowest Exports(as % of merchandise exports) in Nepal?
Make the answer very short. 0.17. What is the difference between the highest and the lowest Exports(as % of merchandise exports) in Nicaragua?
Provide a succinct answer. 5.08. What is the difference between the highest and the lowest Exports(as % of merchandise exports) of Paraguay?
Your answer should be very brief. 0.22. 